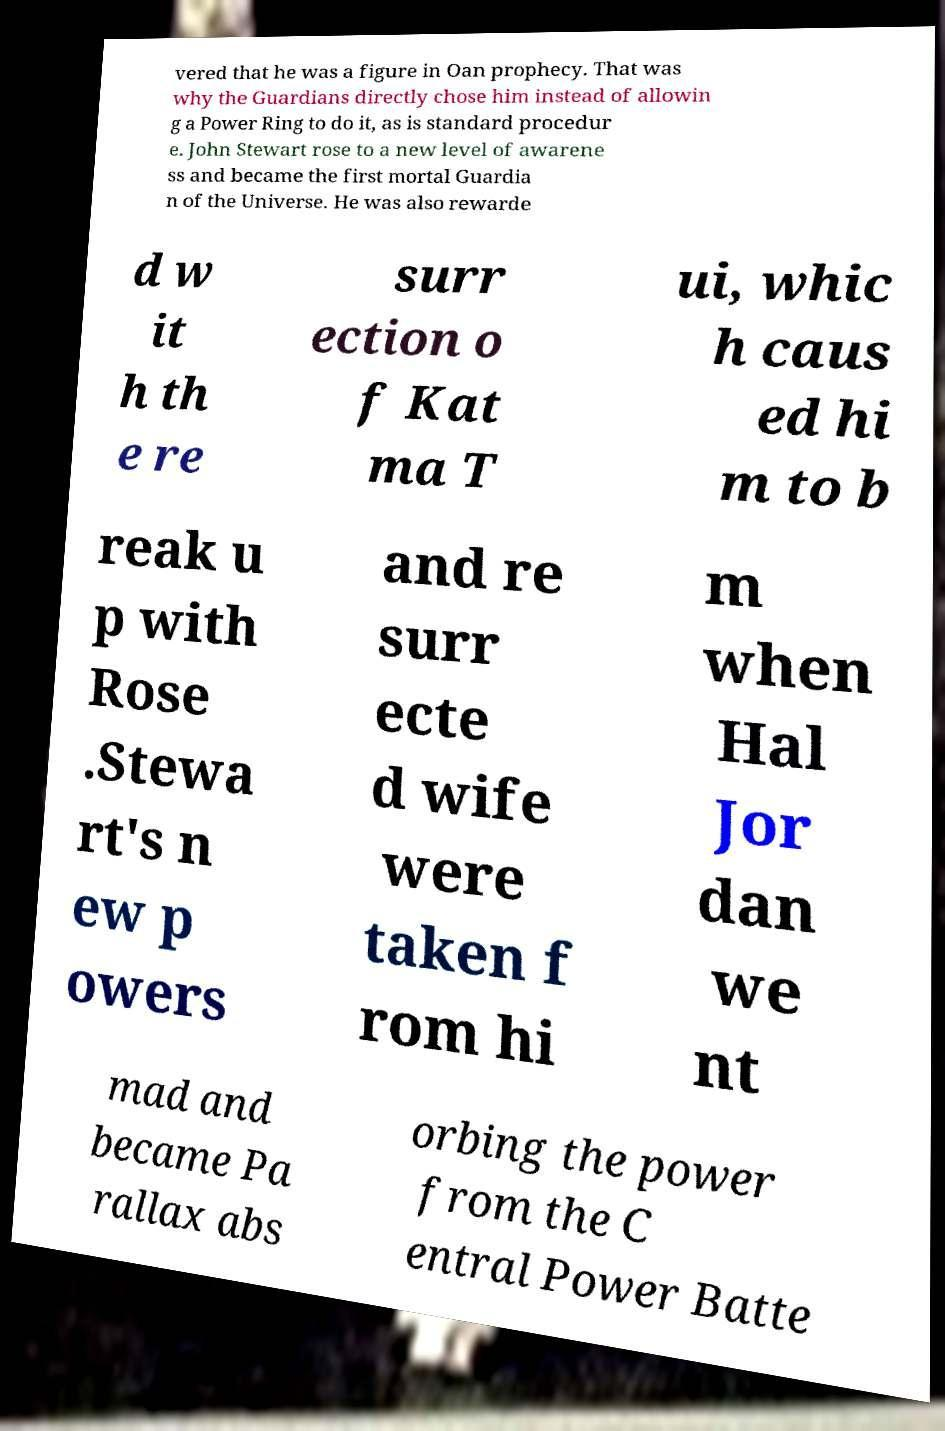What messages or text are displayed in this image? I need them in a readable, typed format. vered that he was a figure in Oan prophecy. That was why the Guardians directly chose him instead of allowin g a Power Ring to do it, as is standard procedur e. John Stewart rose to a new level of awarene ss and became the first mortal Guardia n of the Universe. He was also rewarde d w it h th e re surr ection o f Kat ma T ui, whic h caus ed hi m to b reak u p with Rose .Stewa rt's n ew p owers and re surr ecte d wife were taken f rom hi m when Hal Jor dan we nt mad and became Pa rallax abs orbing the power from the C entral Power Batte 